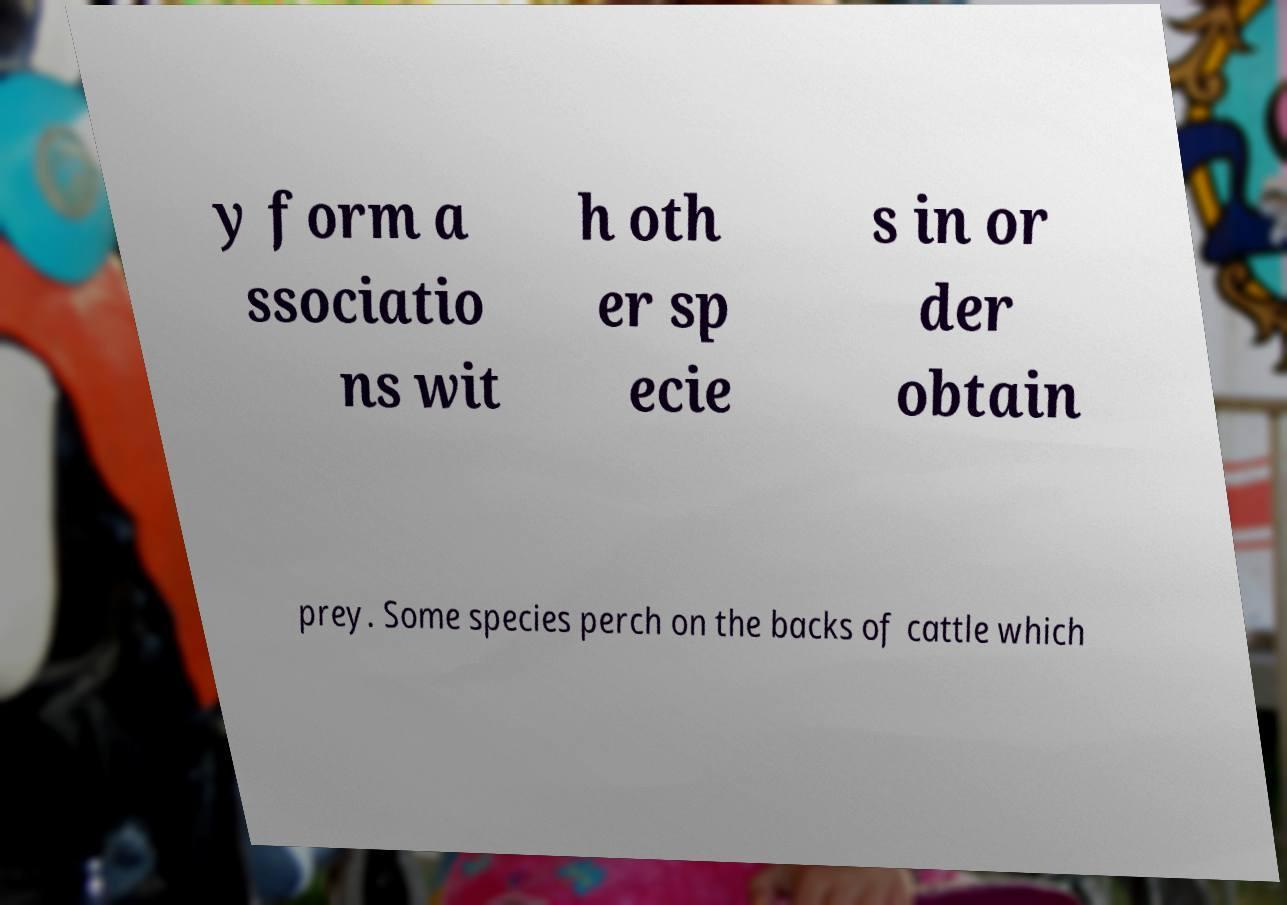There's text embedded in this image that I need extracted. Can you transcribe it verbatim? y form a ssociatio ns wit h oth er sp ecie s in or der obtain prey. Some species perch on the backs of cattle which 